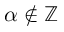<formula> <loc_0><loc_0><loc_500><loc_500>\alpha \not \in \mathbb { Z }</formula> 